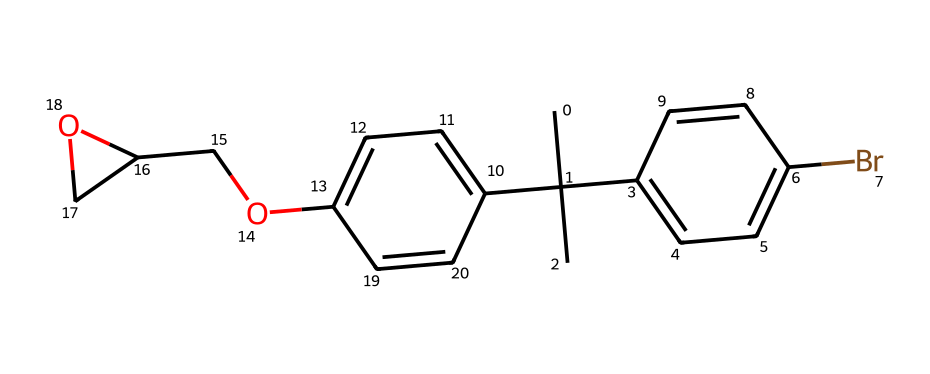how many carbon atoms are in the polymer structure? By examining the SMILES representation, we can count the number of carbon (C) atoms. Each uppercase 'C' corresponds to a carbon atom. In the given SMILES, there are 13 instances of 'C', which indicates the presence of 13 carbon atoms.
Answer: 13 what functional groups are present in the polymer? Functional groups can be identified by looking for specific arrangements in the SMILES. The presence of 'Br' indicates a bromo functional group, and 'OCC' suggests the presence of an ether functional group (R-O-R). Therefore, the functional groups present are bromo and ether.
Answer: bromo, ether how many oxygen atoms are found in the polymer's structure? In the SMILES, we need to identify instances of 'O' which represent oxygen atoms. There are two occurrences of 'O.' Hence, there are 2 oxygen atoms present in the structure.
Answer: 2 what is the significance of the bromine atom in the polymer? The presence of the bromine atom in the polymer indicates that it acts as a flame retardant. Bromine-containing compounds are known for their ability to inhibit combustion, making them valuable in construction materials for safety purposes.
Answer: flame retardant is this polymer an aliphatic or aromatic compound? By analyzing the chemical structure represented in SMILES, we notice multiple benzene rings (indicated by 'c'), which means this compound contains aromatic rings. Therefore, the polymer is classified as aromatic.
Answer: aromatic what is the total number of bonds suggested by the polymer’s structure? To find the total number of bonds in a chemical structure, we generally examine the connectivity of atoms. We consider both single bonds and those implied by the structure. A rough estimate based on the counts of atoms and their typical connectivity will show that there are approximately 16 bonds in total within this structure.
Answer: 16 